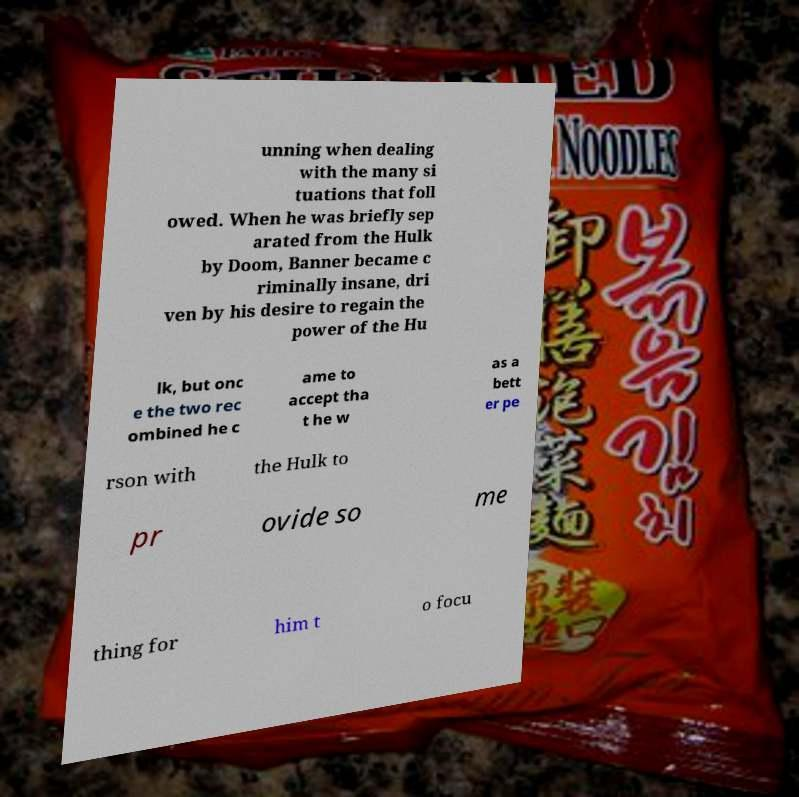Please identify and transcribe the text found in this image. unning when dealing with the many si tuations that foll owed. When he was briefly sep arated from the Hulk by Doom, Banner became c riminally insane, dri ven by his desire to regain the power of the Hu lk, but onc e the two rec ombined he c ame to accept tha t he w as a bett er pe rson with the Hulk to pr ovide so me thing for him t o focu 